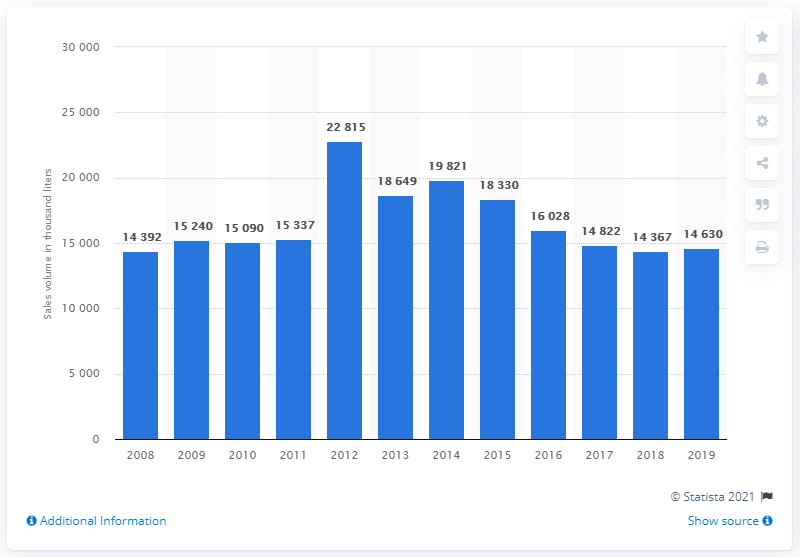Give some essential details in this illustration. In 2019, the sales volume of vodka was 15,090 units. 